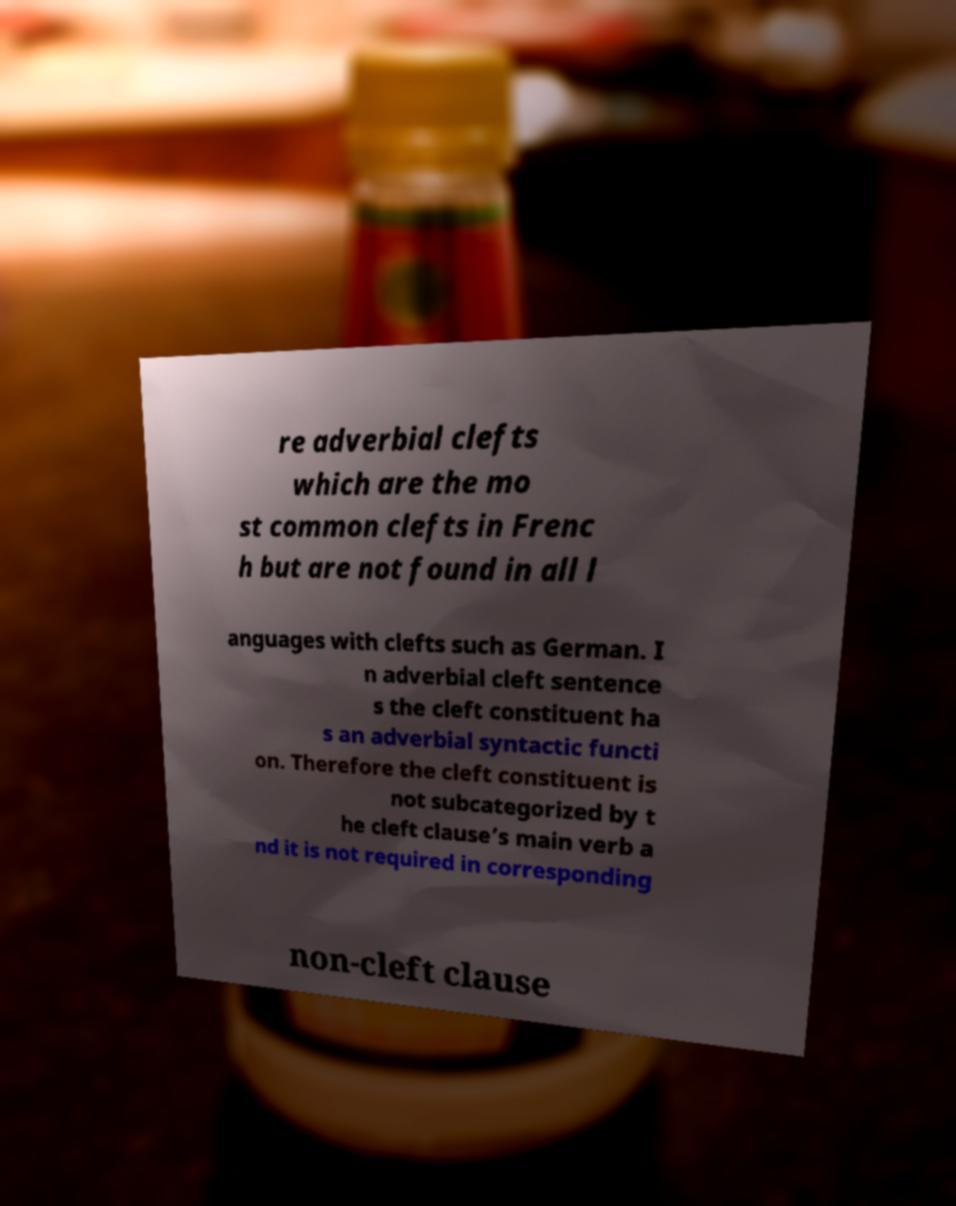Please identify and transcribe the text found in this image. re adverbial clefts which are the mo st common clefts in Frenc h but are not found in all l anguages with clefts such as German. I n adverbial cleft sentence s the cleft constituent ha s an adverbial syntactic functi on. Therefore the cleft constituent is not subcategorized by t he cleft clause’s main verb a nd it is not required in corresponding non-cleft clause 